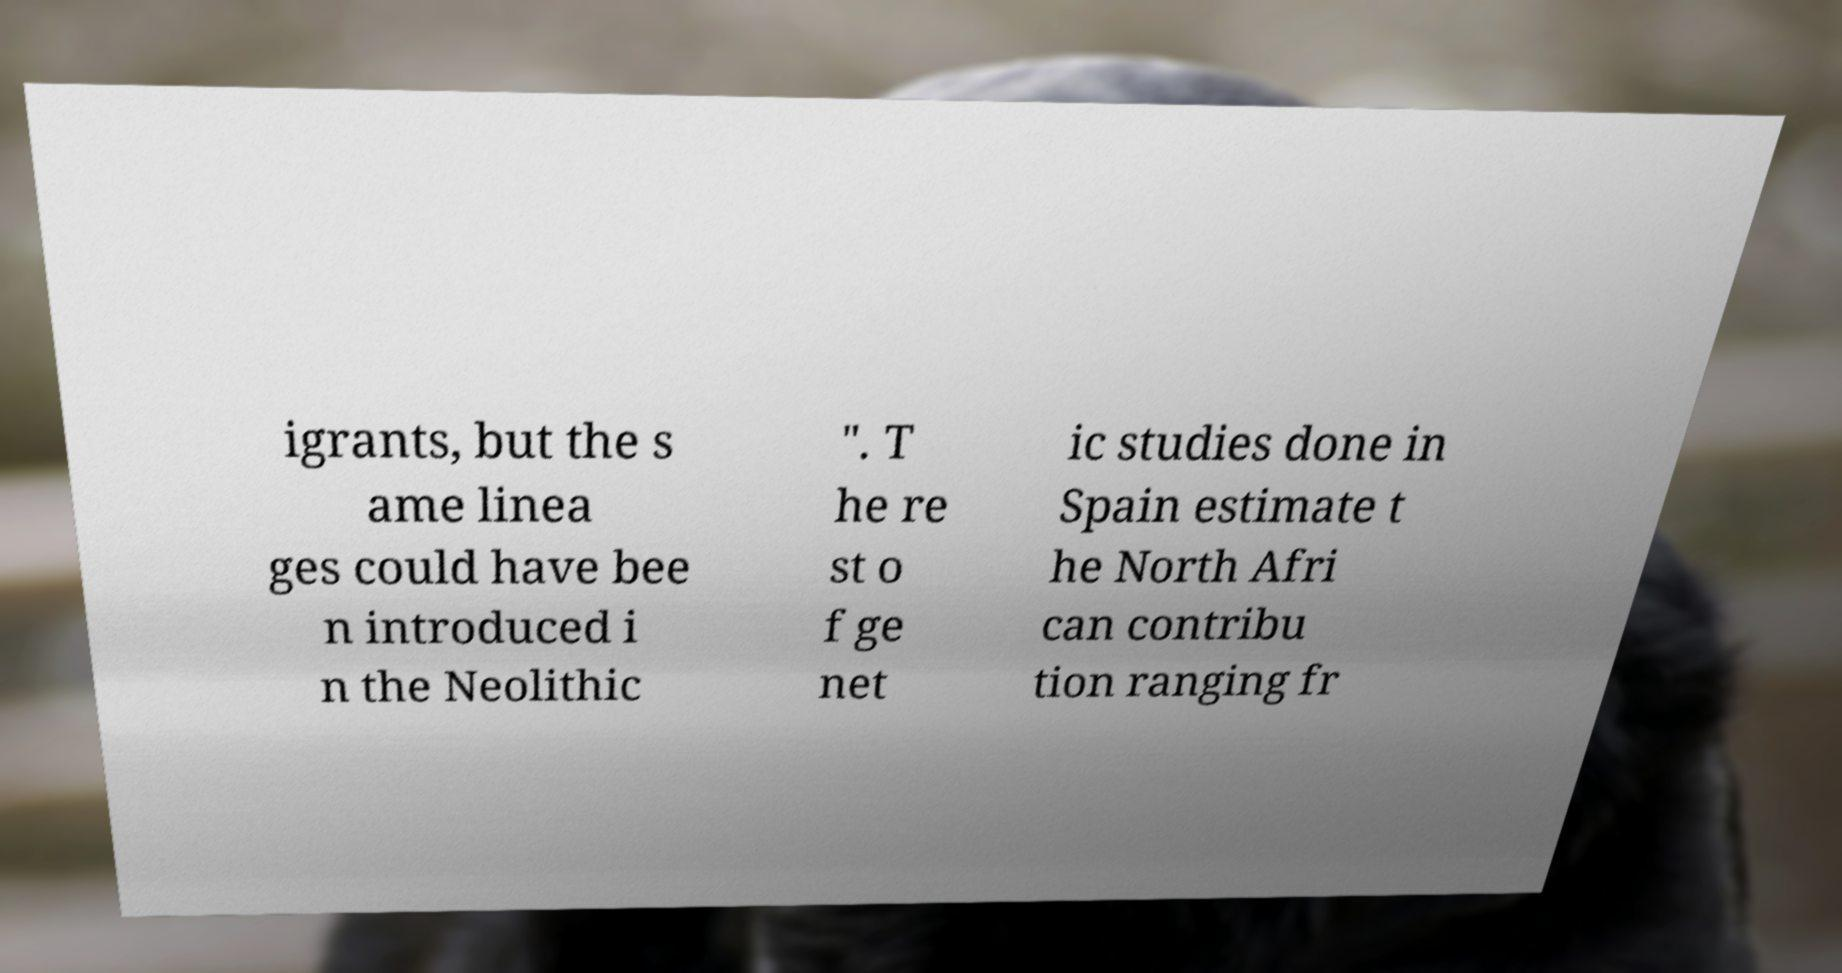Please identify and transcribe the text found in this image. igrants, but the s ame linea ges could have bee n introduced i n the Neolithic ". T he re st o f ge net ic studies done in Spain estimate t he North Afri can contribu tion ranging fr 